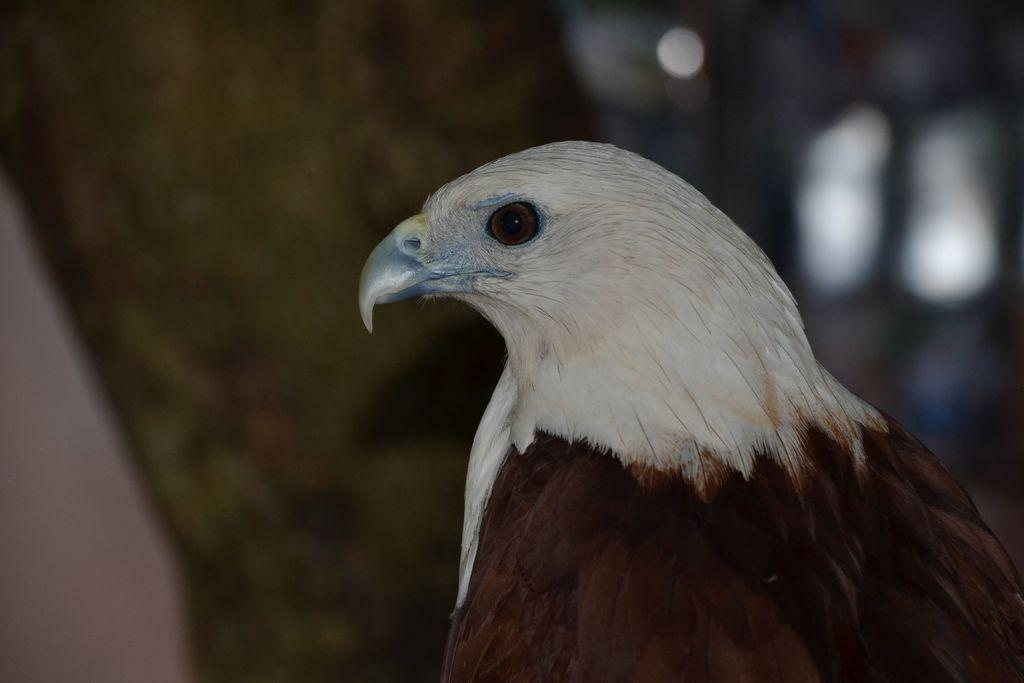What is the main subject of the image? There is a bird in the center of the image. Can you describe the background of the image? There is a tree in the background of the image. What type of amusement can be seen in the image? There is no amusement present in the image; it features a bird and a tree. Can you tell me how many rats are visible in the image? There are no rats visible in the image; it features a bird and a tree. 